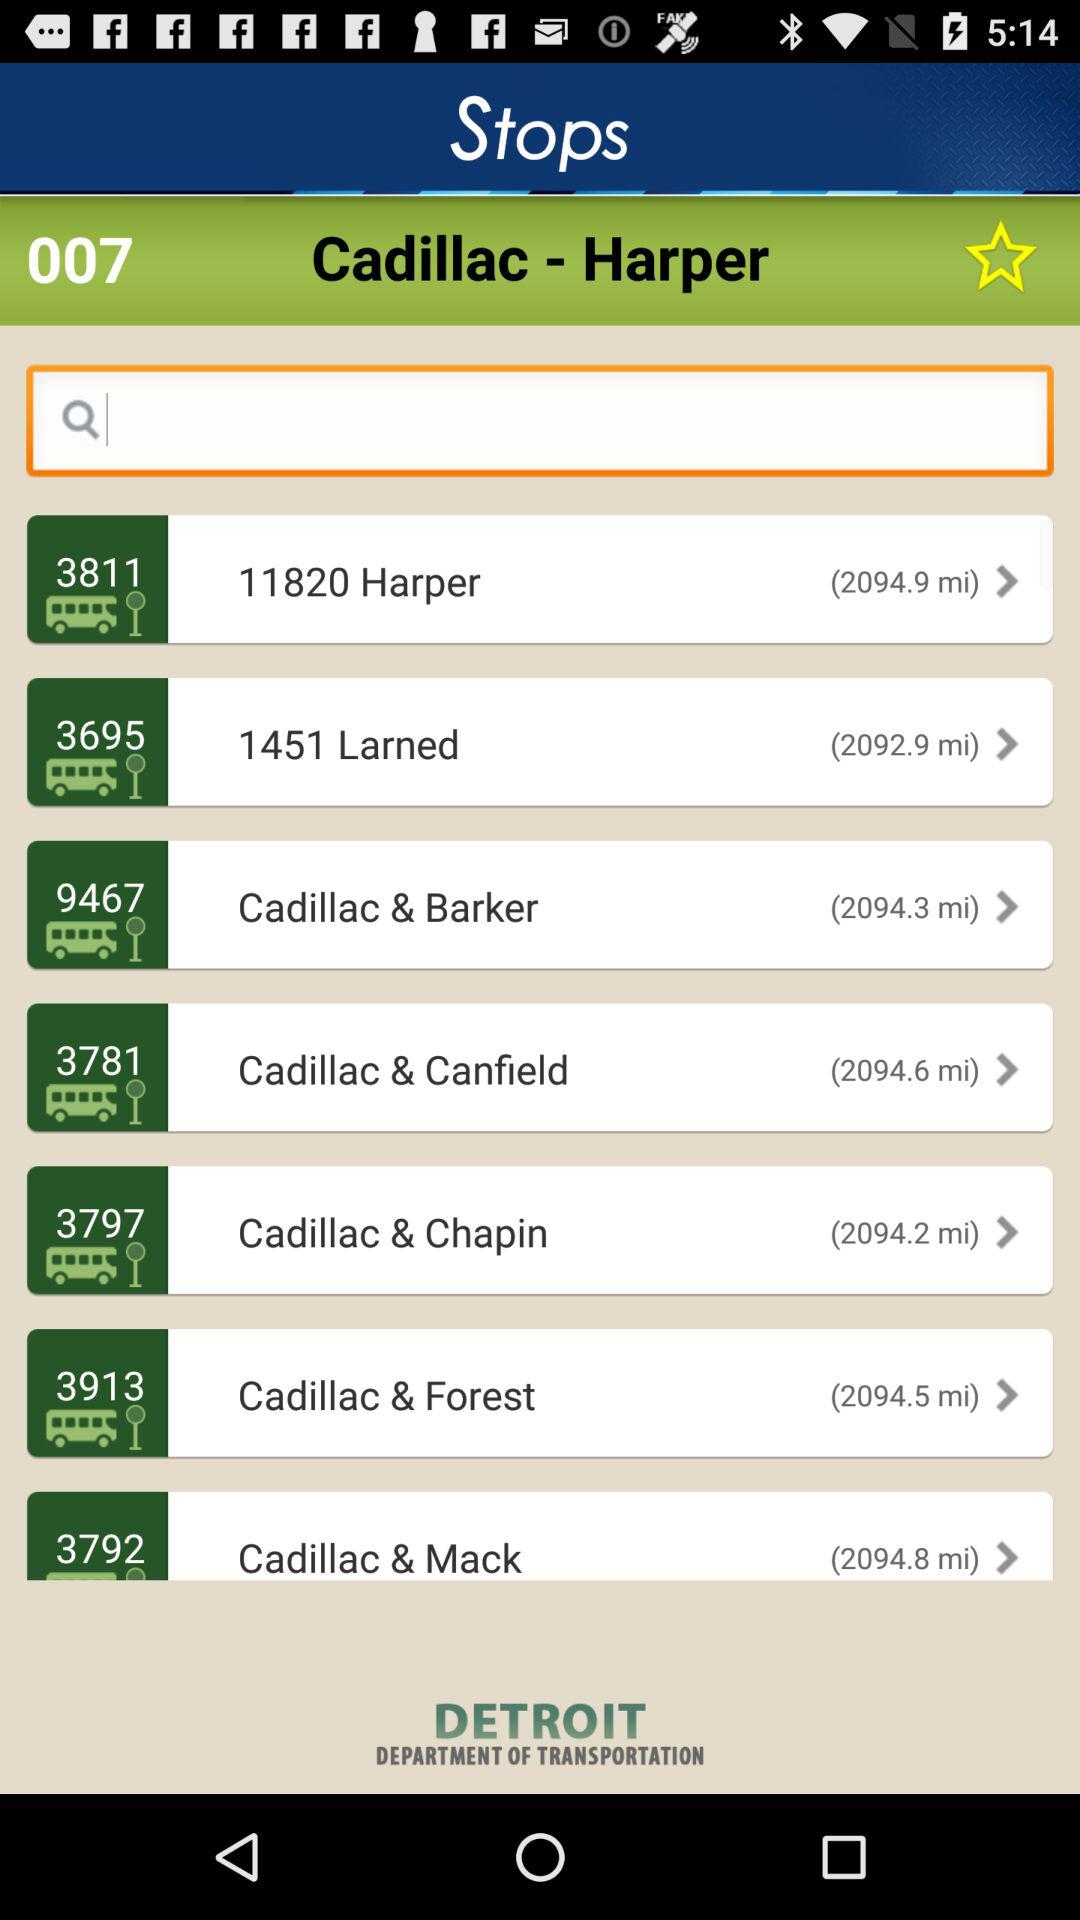The application is designed by whom?
When the provided information is insufficient, respond with <no answer>. <no answer> 